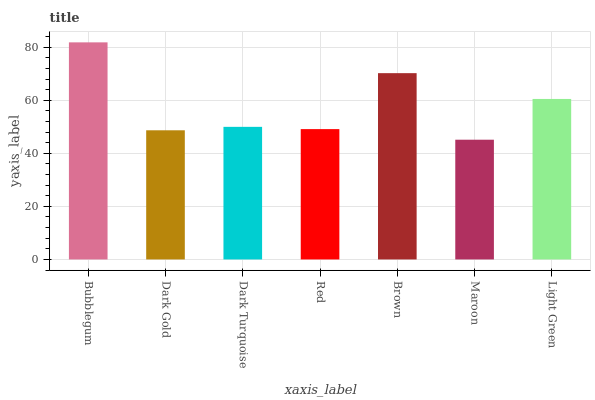Is Maroon the minimum?
Answer yes or no. Yes. Is Bubblegum the maximum?
Answer yes or no. Yes. Is Dark Gold the minimum?
Answer yes or no. No. Is Dark Gold the maximum?
Answer yes or no. No. Is Bubblegum greater than Dark Gold?
Answer yes or no. Yes. Is Dark Gold less than Bubblegum?
Answer yes or no. Yes. Is Dark Gold greater than Bubblegum?
Answer yes or no. No. Is Bubblegum less than Dark Gold?
Answer yes or no. No. Is Dark Turquoise the high median?
Answer yes or no. Yes. Is Dark Turquoise the low median?
Answer yes or no. Yes. Is Dark Gold the high median?
Answer yes or no. No. Is Brown the low median?
Answer yes or no. No. 